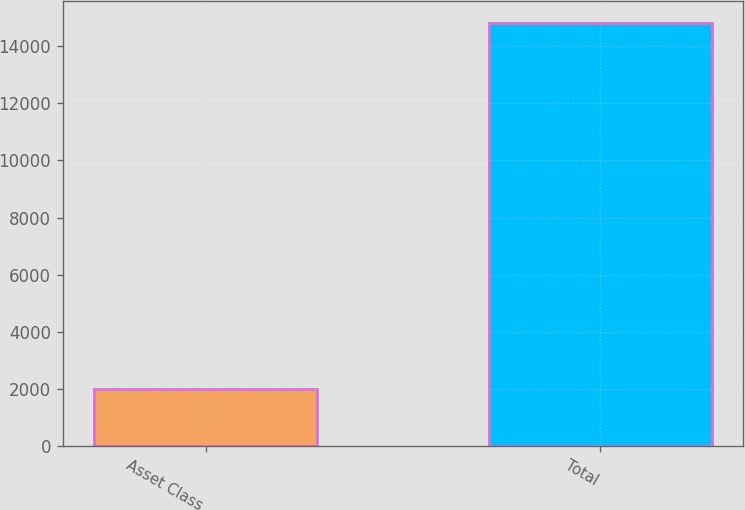Convert chart. <chart><loc_0><loc_0><loc_500><loc_500><bar_chart><fcel>Asset Class<fcel>Total<nl><fcel>2014<fcel>14818<nl></chart> 